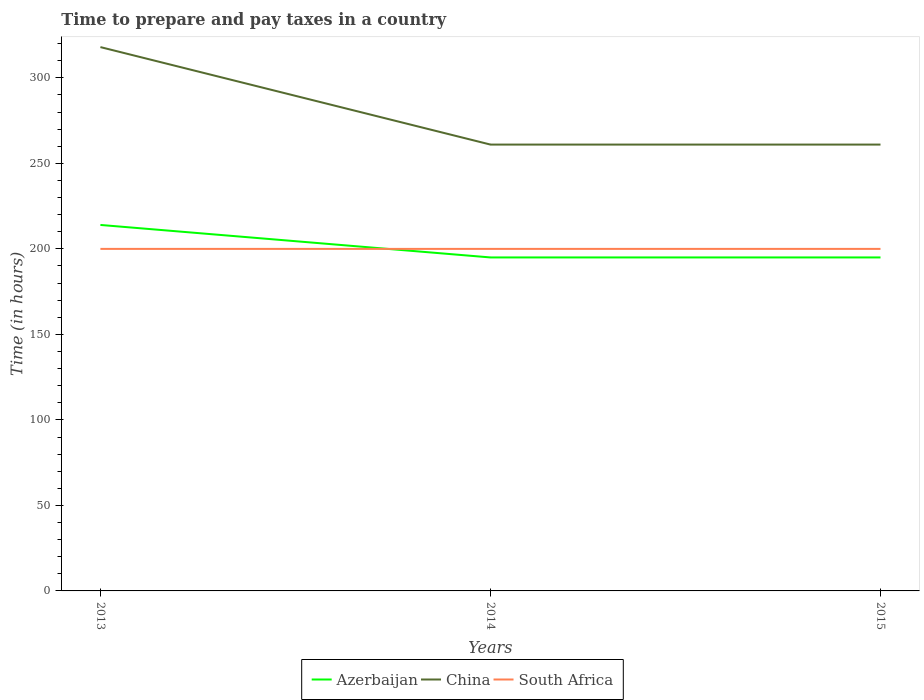How many different coloured lines are there?
Offer a terse response. 3. Does the line corresponding to Azerbaijan intersect with the line corresponding to South Africa?
Your answer should be very brief. Yes. Across all years, what is the maximum number of hours required to prepare and pay taxes in South Africa?
Your answer should be very brief. 200. What is the total number of hours required to prepare and pay taxes in South Africa in the graph?
Provide a short and direct response. 0. What is the difference between the highest and the second highest number of hours required to prepare and pay taxes in China?
Make the answer very short. 57. Is the number of hours required to prepare and pay taxes in China strictly greater than the number of hours required to prepare and pay taxes in Azerbaijan over the years?
Offer a terse response. No. How many years are there in the graph?
Keep it short and to the point. 3. What is the difference between two consecutive major ticks on the Y-axis?
Your response must be concise. 50. Does the graph contain grids?
Keep it short and to the point. No. Where does the legend appear in the graph?
Keep it short and to the point. Bottom center. How many legend labels are there?
Provide a succinct answer. 3. What is the title of the graph?
Make the answer very short. Time to prepare and pay taxes in a country. What is the label or title of the Y-axis?
Your response must be concise. Time (in hours). What is the Time (in hours) of Azerbaijan in 2013?
Give a very brief answer. 214. What is the Time (in hours) in China in 2013?
Ensure brevity in your answer.  318. What is the Time (in hours) of Azerbaijan in 2014?
Your answer should be compact. 195. What is the Time (in hours) in China in 2014?
Provide a succinct answer. 261. What is the Time (in hours) of South Africa in 2014?
Ensure brevity in your answer.  200. What is the Time (in hours) in Azerbaijan in 2015?
Your answer should be compact. 195. What is the Time (in hours) in China in 2015?
Make the answer very short. 261. What is the Time (in hours) of South Africa in 2015?
Your answer should be very brief. 200. Across all years, what is the maximum Time (in hours) in Azerbaijan?
Make the answer very short. 214. Across all years, what is the maximum Time (in hours) of China?
Give a very brief answer. 318. Across all years, what is the maximum Time (in hours) in South Africa?
Keep it short and to the point. 200. Across all years, what is the minimum Time (in hours) in Azerbaijan?
Your answer should be compact. 195. Across all years, what is the minimum Time (in hours) in China?
Make the answer very short. 261. Across all years, what is the minimum Time (in hours) in South Africa?
Make the answer very short. 200. What is the total Time (in hours) in Azerbaijan in the graph?
Give a very brief answer. 604. What is the total Time (in hours) of China in the graph?
Make the answer very short. 840. What is the total Time (in hours) in South Africa in the graph?
Keep it short and to the point. 600. What is the difference between the Time (in hours) of Azerbaijan in 2013 and that in 2014?
Provide a succinct answer. 19. What is the difference between the Time (in hours) of China in 2013 and that in 2014?
Offer a terse response. 57. What is the difference between the Time (in hours) in South Africa in 2013 and that in 2014?
Your response must be concise. 0. What is the difference between the Time (in hours) in Azerbaijan in 2013 and that in 2015?
Provide a short and direct response. 19. What is the difference between the Time (in hours) of China in 2013 and that in 2015?
Ensure brevity in your answer.  57. What is the difference between the Time (in hours) in South Africa in 2013 and that in 2015?
Offer a terse response. 0. What is the difference between the Time (in hours) in South Africa in 2014 and that in 2015?
Your answer should be compact. 0. What is the difference between the Time (in hours) in Azerbaijan in 2013 and the Time (in hours) in China in 2014?
Give a very brief answer. -47. What is the difference between the Time (in hours) in Azerbaijan in 2013 and the Time (in hours) in South Africa in 2014?
Make the answer very short. 14. What is the difference between the Time (in hours) in China in 2013 and the Time (in hours) in South Africa in 2014?
Keep it short and to the point. 118. What is the difference between the Time (in hours) in Azerbaijan in 2013 and the Time (in hours) in China in 2015?
Your answer should be very brief. -47. What is the difference between the Time (in hours) in Azerbaijan in 2013 and the Time (in hours) in South Africa in 2015?
Keep it short and to the point. 14. What is the difference between the Time (in hours) of China in 2013 and the Time (in hours) of South Africa in 2015?
Provide a succinct answer. 118. What is the difference between the Time (in hours) of Azerbaijan in 2014 and the Time (in hours) of China in 2015?
Provide a short and direct response. -66. What is the average Time (in hours) of Azerbaijan per year?
Your answer should be very brief. 201.33. What is the average Time (in hours) in China per year?
Give a very brief answer. 280. What is the average Time (in hours) in South Africa per year?
Offer a terse response. 200. In the year 2013, what is the difference between the Time (in hours) of Azerbaijan and Time (in hours) of China?
Your response must be concise. -104. In the year 2013, what is the difference between the Time (in hours) in China and Time (in hours) in South Africa?
Offer a terse response. 118. In the year 2014, what is the difference between the Time (in hours) of Azerbaijan and Time (in hours) of China?
Your response must be concise. -66. In the year 2014, what is the difference between the Time (in hours) of Azerbaijan and Time (in hours) of South Africa?
Offer a terse response. -5. In the year 2014, what is the difference between the Time (in hours) in China and Time (in hours) in South Africa?
Give a very brief answer. 61. In the year 2015, what is the difference between the Time (in hours) in Azerbaijan and Time (in hours) in China?
Give a very brief answer. -66. What is the ratio of the Time (in hours) of Azerbaijan in 2013 to that in 2014?
Keep it short and to the point. 1.1. What is the ratio of the Time (in hours) of China in 2013 to that in 2014?
Your answer should be very brief. 1.22. What is the ratio of the Time (in hours) in South Africa in 2013 to that in 2014?
Keep it short and to the point. 1. What is the ratio of the Time (in hours) in Azerbaijan in 2013 to that in 2015?
Your response must be concise. 1.1. What is the ratio of the Time (in hours) in China in 2013 to that in 2015?
Your answer should be compact. 1.22. What is the ratio of the Time (in hours) of Azerbaijan in 2014 to that in 2015?
Provide a succinct answer. 1. What is the difference between the highest and the second highest Time (in hours) of South Africa?
Make the answer very short. 0. What is the difference between the highest and the lowest Time (in hours) in Azerbaijan?
Your response must be concise. 19. 